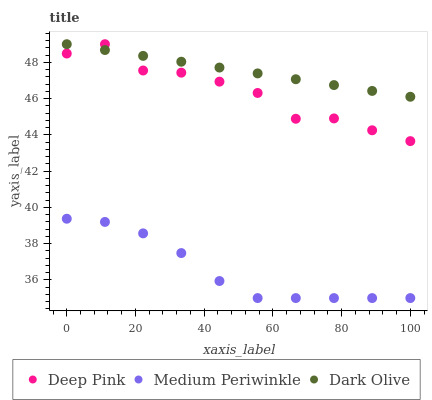Does Medium Periwinkle have the minimum area under the curve?
Answer yes or no. Yes. Does Dark Olive have the maximum area under the curve?
Answer yes or no. Yes. Does Deep Pink have the minimum area under the curve?
Answer yes or no. No. Does Deep Pink have the maximum area under the curve?
Answer yes or no. No. Is Dark Olive the smoothest?
Answer yes or no. Yes. Is Deep Pink the roughest?
Answer yes or no. Yes. Is Medium Periwinkle the smoothest?
Answer yes or no. No. Is Medium Periwinkle the roughest?
Answer yes or no. No. Does Medium Periwinkle have the lowest value?
Answer yes or no. Yes. Does Deep Pink have the lowest value?
Answer yes or no. No. Does Deep Pink have the highest value?
Answer yes or no. Yes. Does Medium Periwinkle have the highest value?
Answer yes or no. No. Is Medium Periwinkle less than Dark Olive?
Answer yes or no. Yes. Is Dark Olive greater than Medium Periwinkle?
Answer yes or no. Yes. Does Dark Olive intersect Deep Pink?
Answer yes or no. Yes. Is Dark Olive less than Deep Pink?
Answer yes or no. No. Is Dark Olive greater than Deep Pink?
Answer yes or no. No. Does Medium Periwinkle intersect Dark Olive?
Answer yes or no. No. 